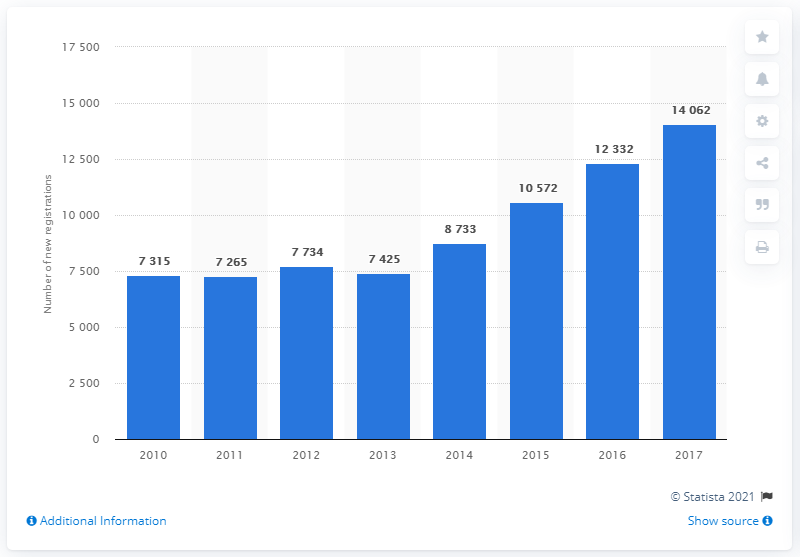Mention a couple of crucial points in this snapshot. In 2017, there were 14,062 registrations of motorhomes. In 2017, the number of motorhome registrations increased significantly from 7,000 in 2010 to over 14,000. 